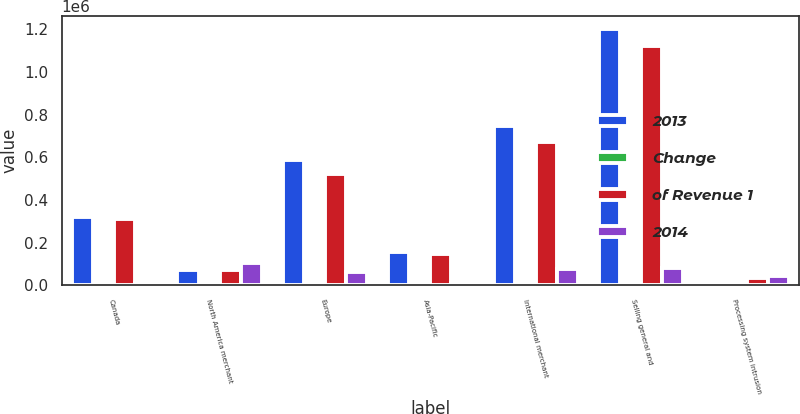Convert chart. <chart><loc_0><loc_0><loc_500><loc_500><stacked_bar_chart><ecel><fcel>Canada<fcel>North America merchant<fcel>Europe<fcel>Asia-Pacific<fcel>International merchant<fcel>Selling general and<fcel>Processing system intrusion<nl><fcel>2013<fcel>320333<fcel>69933<fcel>587463<fcel>157781<fcel>745244<fcel>1.20351e+06<fcel>7000<nl><fcel>Change<fcel>12.5<fcel>70.8<fcel>23<fcel>6.2<fcel>29.2<fcel>47.1<fcel>0.3<nl><fcel>of Revenue 1<fcel>311000<fcel>69933<fcel>522593<fcel>147655<fcel>670248<fcel>1.11986e+06<fcel>36775<nl><fcel>2014<fcel>9333<fcel>103317<fcel>64870<fcel>10126<fcel>74996<fcel>83652<fcel>43775<nl></chart> 